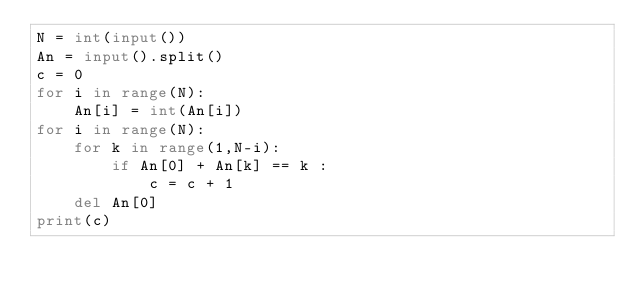Convert code to text. <code><loc_0><loc_0><loc_500><loc_500><_Python_>N = int(input())
An = input().split()
c = 0
for i in range(N):
    An[i] = int(An[i])
for i in range(N):
    for k in range(1,N-i):
        if An[0] + An[k] == k :
            c = c + 1
    del An[0]
print(c)
</code> 